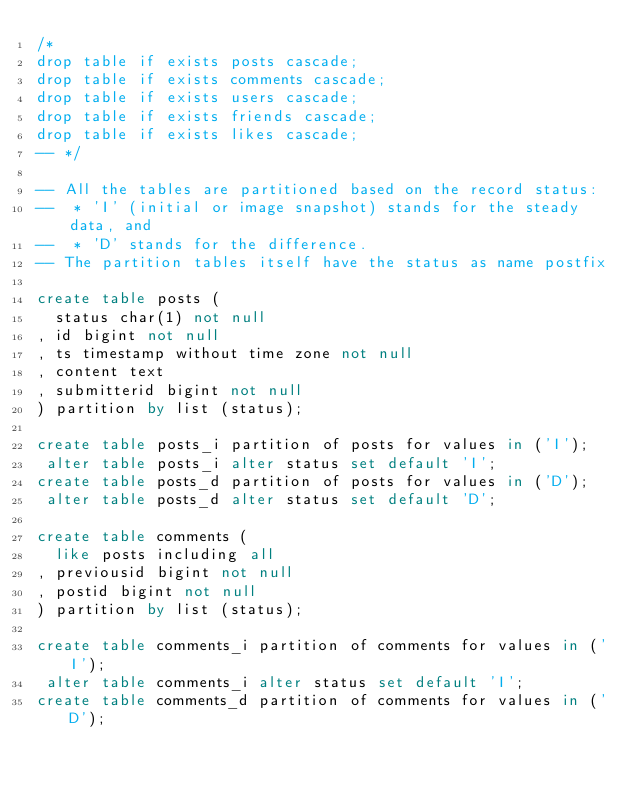Convert code to text. <code><loc_0><loc_0><loc_500><loc_500><_SQL_>/*
drop table if exists posts cascade;
drop table if exists comments cascade;
drop table if exists users cascade;
drop table if exists friends cascade;
drop table if exists likes cascade;
-- */

-- All the tables are partitioned based on the record status:
--  * 'I' (initial or image snapshot) stands for the steady data, and
--  * 'D' stands for the difference.
-- The partition tables itself have the status as name postfix

create table posts (
  status char(1) not null
, id bigint not null
, ts timestamp without time zone not null
, content text
, submitterid bigint not null
) partition by list (status);

create table posts_i partition of posts for values in ('I');
 alter table posts_i alter status set default 'I';
create table posts_d partition of posts for values in ('D');
 alter table posts_d alter status set default 'D';

create table comments (
  like posts including all
, previousid bigint not null
, postid bigint not null
) partition by list (status);

create table comments_i partition of comments for values in ('I');
 alter table comments_i alter status set default 'I';
create table comments_d partition of comments for values in ('D');</code> 